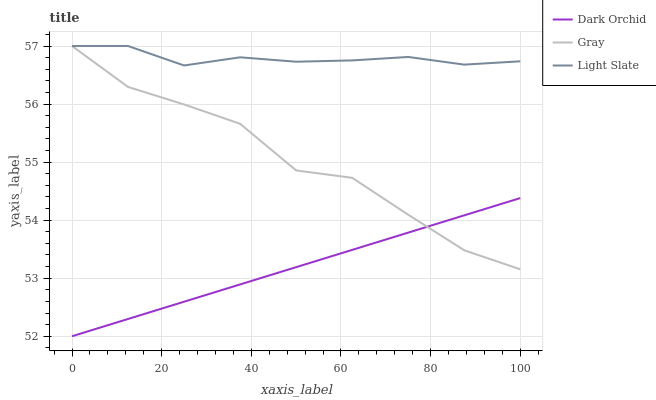Does Dark Orchid have the minimum area under the curve?
Answer yes or no. Yes. Does Light Slate have the maximum area under the curve?
Answer yes or no. Yes. Does Gray have the minimum area under the curve?
Answer yes or no. No. Does Gray have the maximum area under the curve?
Answer yes or no. No. Is Dark Orchid the smoothest?
Answer yes or no. Yes. Is Gray the roughest?
Answer yes or no. Yes. Is Gray the smoothest?
Answer yes or no. No. Is Dark Orchid the roughest?
Answer yes or no. No. Does Dark Orchid have the lowest value?
Answer yes or no. Yes. Does Gray have the lowest value?
Answer yes or no. No. Does Gray have the highest value?
Answer yes or no. Yes. Does Dark Orchid have the highest value?
Answer yes or no. No. Is Dark Orchid less than Light Slate?
Answer yes or no. Yes. Is Light Slate greater than Dark Orchid?
Answer yes or no. Yes. Does Dark Orchid intersect Gray?
Answer yes or no. Yes. Is Dark Orchid less than Gray?
Answer yes or no. No. Is Dark Orchid greater than Gray?
Answer yes or no. No. Does Dark Orchid intersect Light Slate?
Answer yes or no. No. 